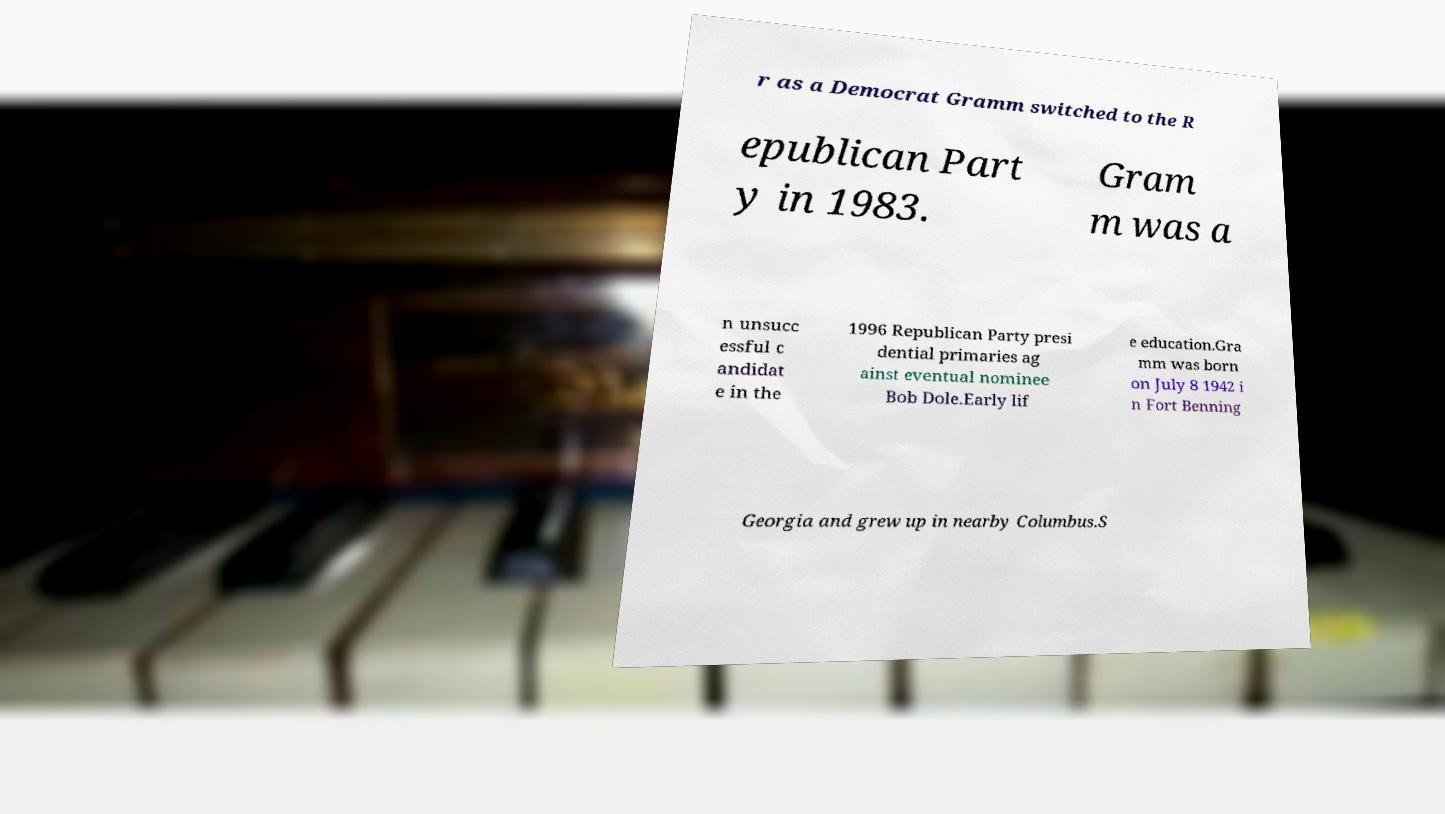I need the written content from this picture converted into text. Can you do that? r as a Democrat Gramm switched to the R epublican Part y in 1983. Gram m was a n unsucc essful c andidat e in the 1996 Republican Party presi dential primaries ag ainst eventual nominee Bob Dole.Early lif e education.Gra mm was born on July 8 1942 i n Fort Benning Georgia and grew up in nearby Columbus.S 